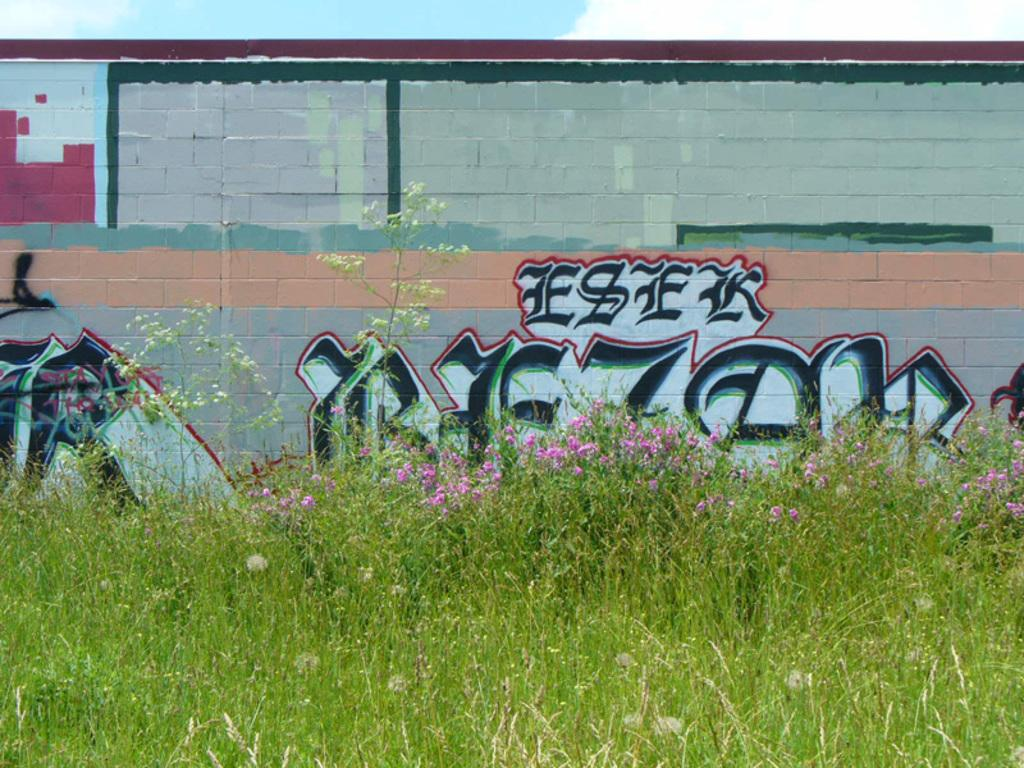What type of surface is covered with graffiti in the image? There is a brick wall with graffiti in the image. What can be seen on the ground in the image? There is grass and flowers on the ground in the image. How many trains are visible in the image? There are no trains present in the image. What type of adjustment can be made to the square in the image? There is no square present in the image. 